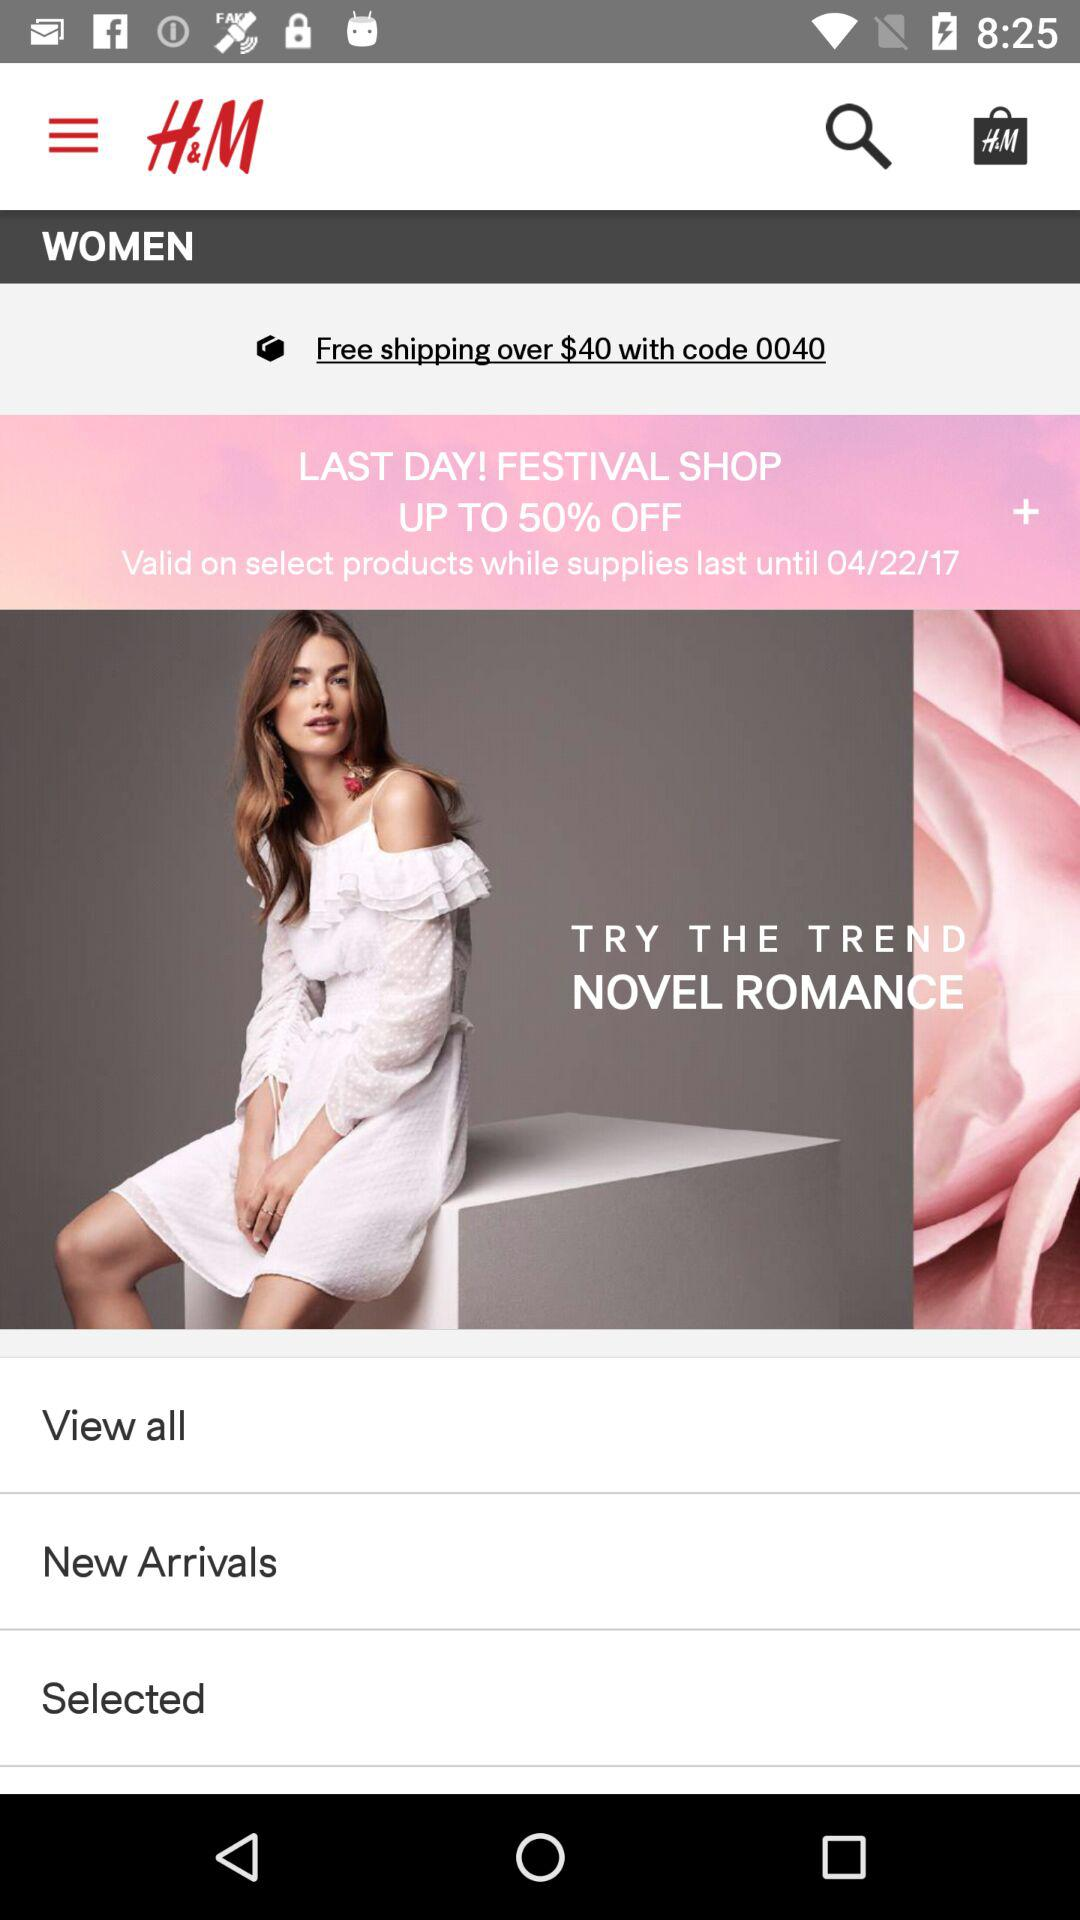What is the code for free shipping? The code for free shipping is 0040. 